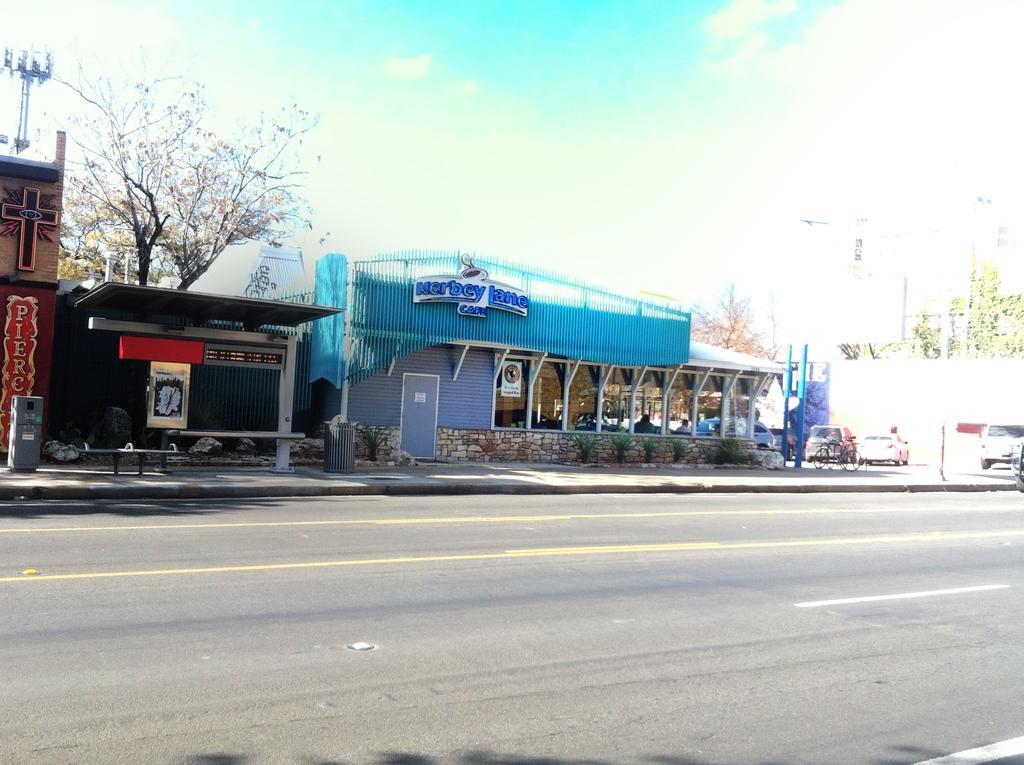Can you describe this image briefly? This picture is clicked outside the city. At the bottom, we see the road. On the right side, we see the cars parked on the road. Behind that, we see the buildings and the trees. In the middle, we see a building in blue and grey color. We see some text written on top of the building. We see a board in white color with some text written on it. On the left side, we see a building and a bus stop. We see a board in brown color with some text written on it. Beside that, we see a garbage bin and the benches in the bus stop. We see the boards in red and white color. There are trees, buildings and the poles in the background. At the top, we see the sky and the clouds. 